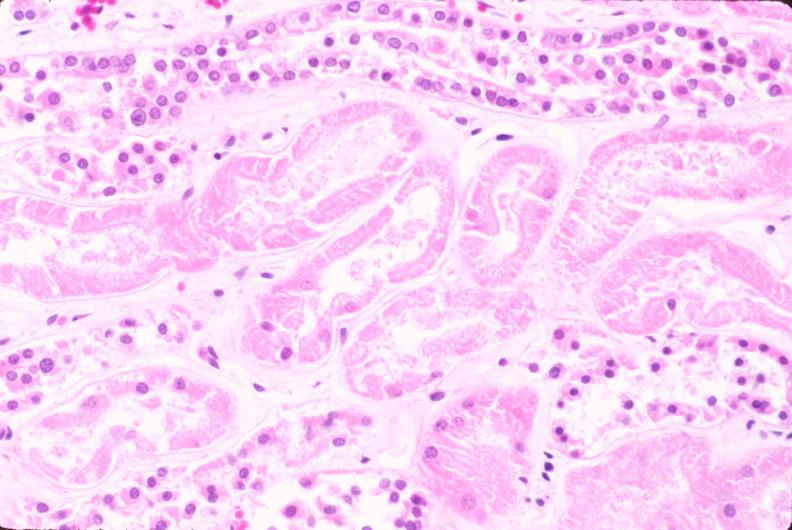what does this image show?
Answer the question using a single word or phrase. Kidney 